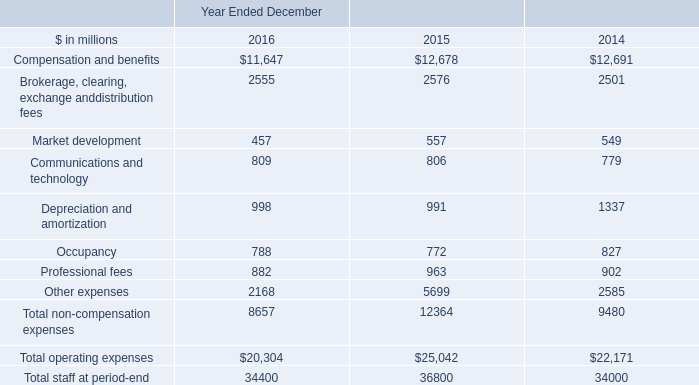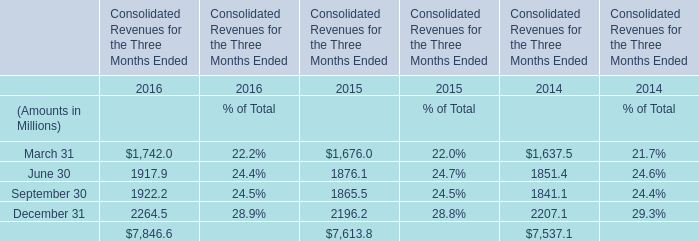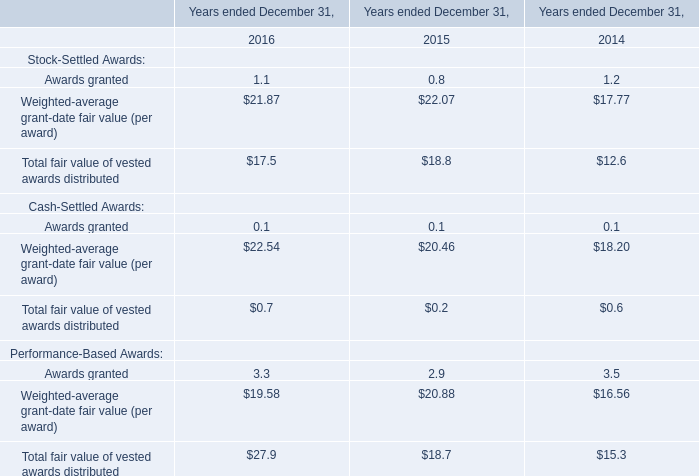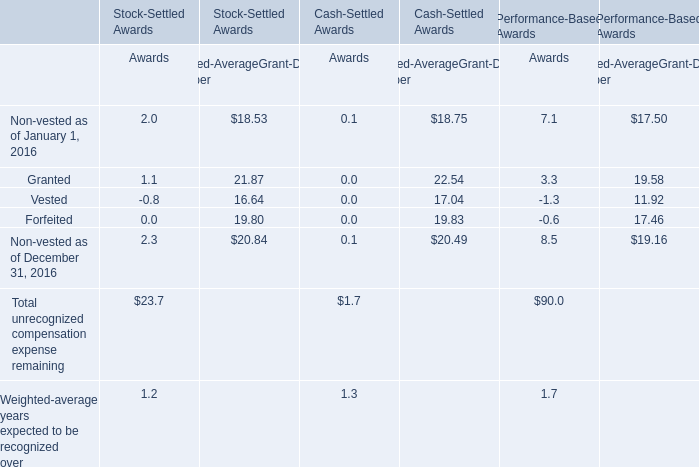What's the sum of all Awards that are positive in 2016 for Stock-Settled Awards? 
Computations: ((((2.0 + 1.1) + 2.3) + 23.7) + 1.2)
Answer: 30.3. 